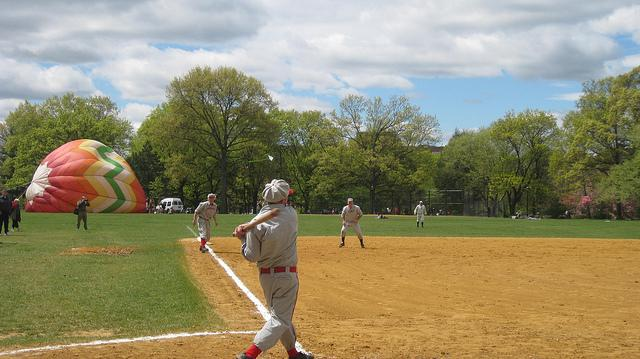What type of transport is visible here? Please explain your reasoning. hotair balloon. The balloon is on the ground. 